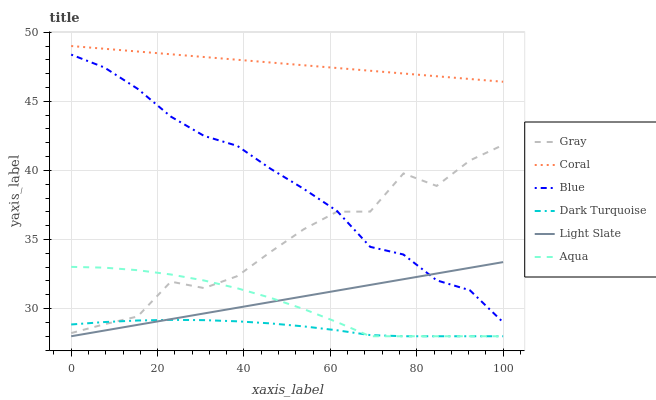Does Dark Turquoise have the minimum area under the curve?
Answer yes or no. Yes. Does Coral have the maximum area under the curve?
Answer yes or no. Yes. Does Gray have the minimum area under the curve?
Answer yes or no. No. Does Gray have the maximum area under the curve?
Answer yes or no. No. Is Light Slate the smoothest?
Answer yes or no. Yes. Is Gray the roughest?
Answer yes or no. Yes. Is Gray the smoothest?
Answer yes or no. No. Is Light Slate the roughest?
Answer yes or no. No. Does Light Slate have the lowest value?
Answer yes or no. Yes. Does Gray have the lowest value?
Answer yes or no. No. Does Coral have the highest value?
Answer yes or no. Yes. Does Gray have the highest value?
Answer yes or no. No. Is Aqua less than Blue?
Answer yes or no. Yes. Is Coral greater than Aqua?
Answer yes or no. Yes. Does Gray intersect Blue?
Answer yes or no. Yes. Is Gray less than Blue?
Answer yes or no. No. Is Gray greater than Blue?
Answer yes or no. No. Does Aqua intersect Blue?
Answer yes or no. No. 